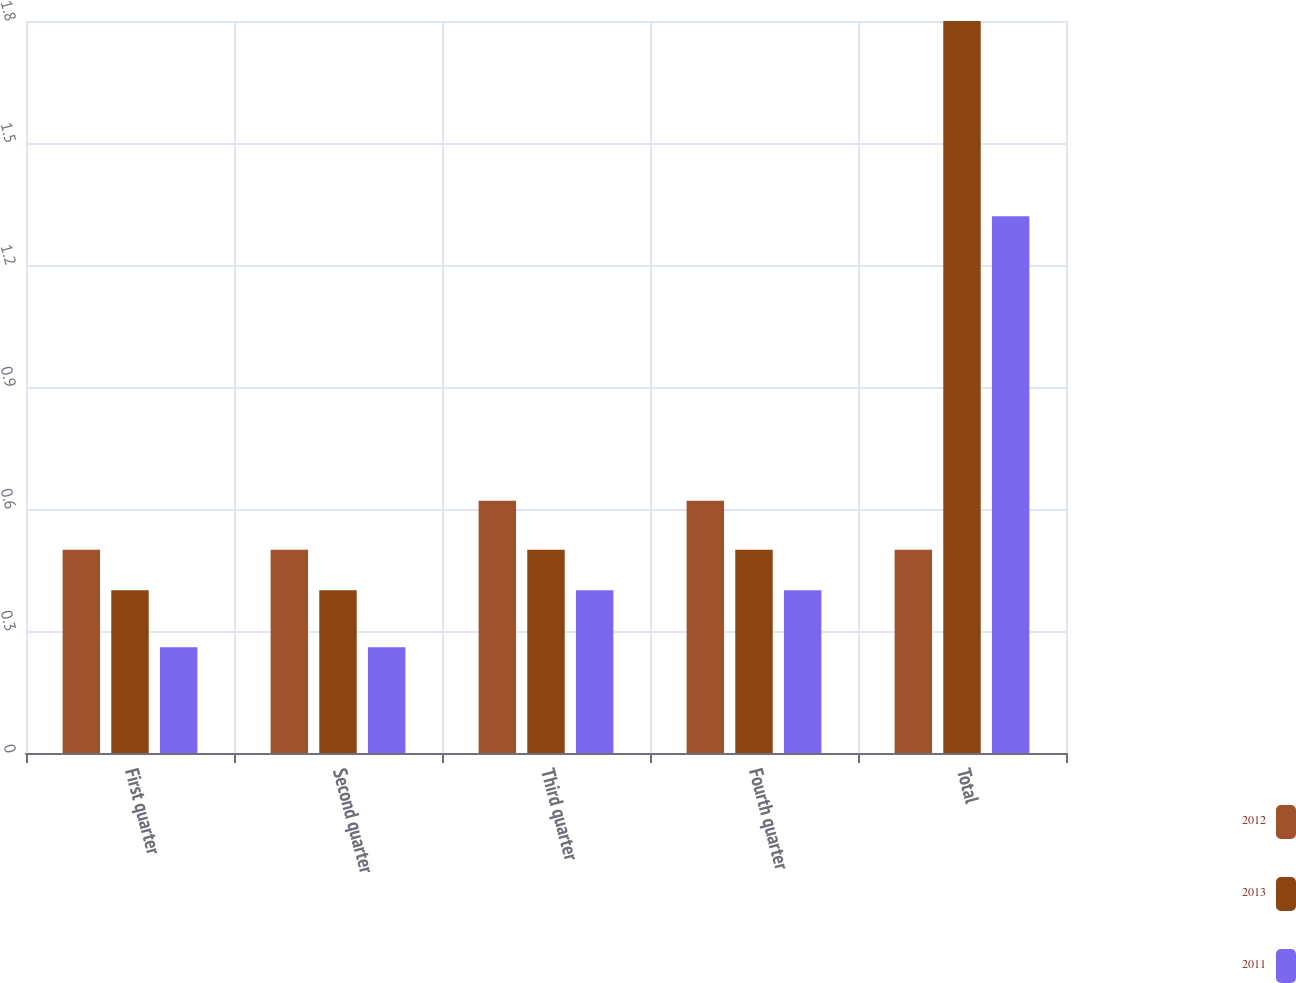Convert chart. <chart><loc_0><loc_0><loc_500><loc_500><stacked_bar_chart><ecel><fcel>First quarter<fcel>Second quarter<fcel>Third quarter<fcel>Fourth quarter<fcel>Total<nl><fcel>2012<fcel>0.5<fcel>0.5<fcel>0.62<fcel>0.62<fcel>0.5<nl><fcel>2013<fcel>0.4<fcel>0.4<fcel>0.5<fcel>0.5<fcel>1.8<nl><fcel>2011<fcel>0.26<fcel>0.26<fcel>0.4<fcel>0.4<fcel>1.32<nl></chart> 